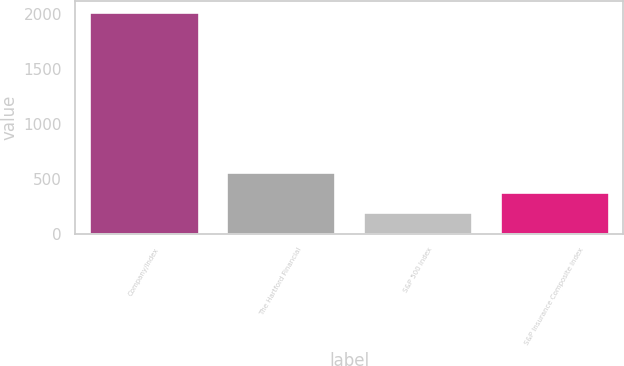Convert chart to OTSL. <chart><loc_0><loc_0><loc_500><loc_500><bar_chart><fcel>Company/Index<fcel>The Hartford Financial<fcel>S&P 500 Index<fcel>S&P Insurance Composite Index<nl><fcel>2016<fcel>561.74<fcel>198.18<fcel>379.96<nl></chart> 